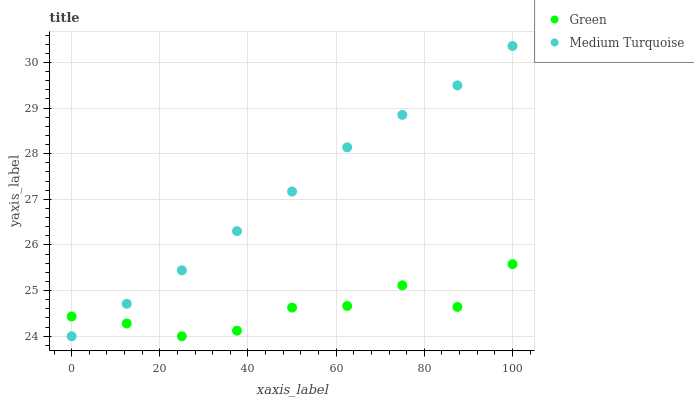Does Green have the minimum area under the curve?
Answer yes or no. Yes. Does Medium Turquoise have the maximum area under the curve?
Answer yes or no. Yes. Does Medium Turquoise have the minimum area under the curve?
Answer yes or no. No. Is Medium Turquoise the smoothest?
Answer yes or no. Yes. Is Green the roughest?
Answer yes or no. Yes. Is Medium Turquoise the roughest?
Answer yes or no. No. Does Green have the lowest value?
Answer yes or no. Yes. Does Medium Turquoise have the highest value?
Answer yes or no. Yes. Does Medium Turquoise intersect Green?
Answer yes or no. Yes. Is Medium Turquoise less than Green?
Answer yes or no. No. Is Medium Turquoise greater than Green?
Answer yes or no. No. 